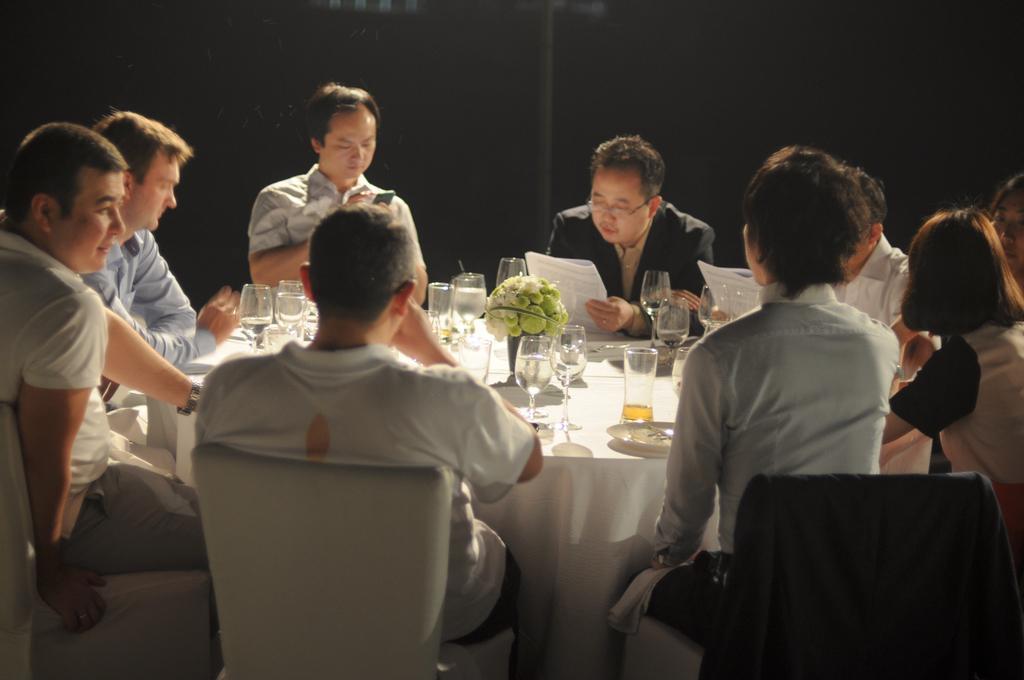In one or two sentences, can you explain what this image depicts? There are few people sitting on the chair around the table. There are glasses,flower vase,plates on the table and two men are holding paper in their hands and looking at it. 